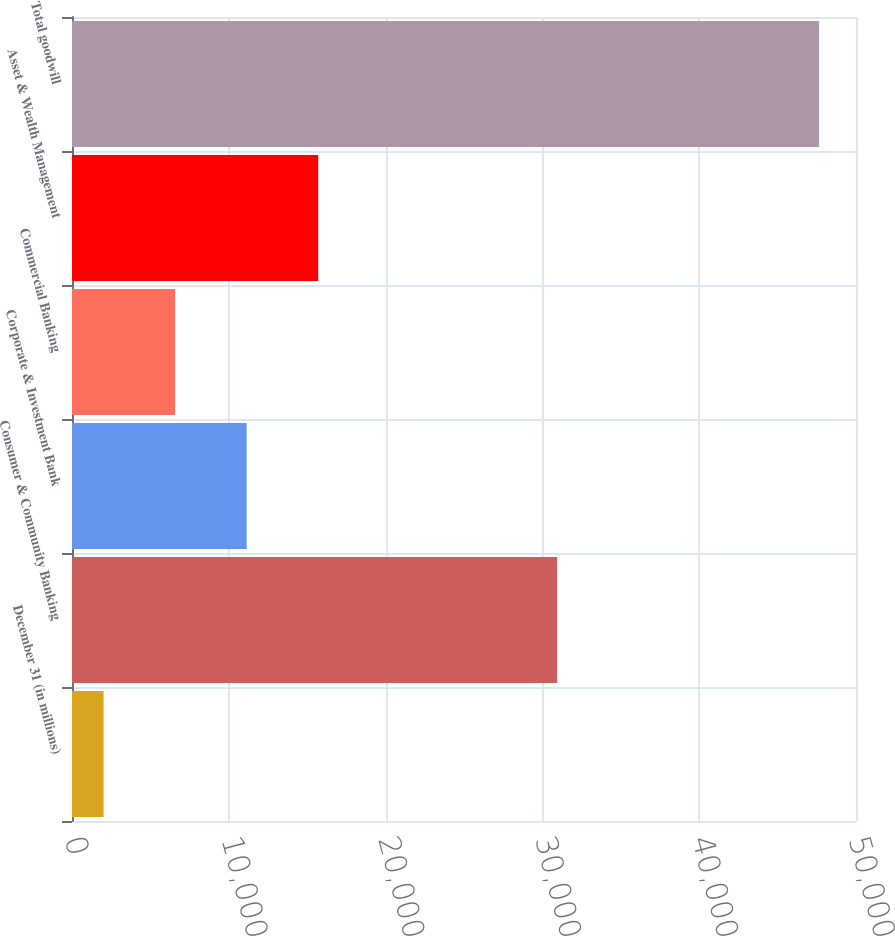<chart> <loc_0><loc_0><loc_500><loc_500><bar_chart><fcel>December 31 (in millions)<fcel>Consumer & Community Banking<fcel>Corporate & Investment Bank<fcel>Commercial Banking<fcel>Asset & Wealth Management<fcel>Total goodwill<nl><fcel>2014<fcel>30941<fcel>11140.6<fcel>6577.3<fcel>15703.9<fcel>47647<nl></chart> 